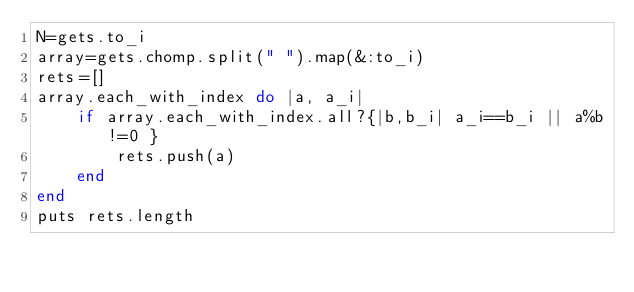Convert code to text. <code><loc_0><loc_0><loc_500><loc_500><_Ruby_>N=gets.to_i
array=gets.chomp.split(" ").map(&:to_i)
rets=[]
array.each_with_index do |a, a_i|
    if array.each_with_index.all?{|b,b_i| a_i==b_i || a%b!=0 }
        rets.push(a)
    end
end
puts rets.length
</code> 